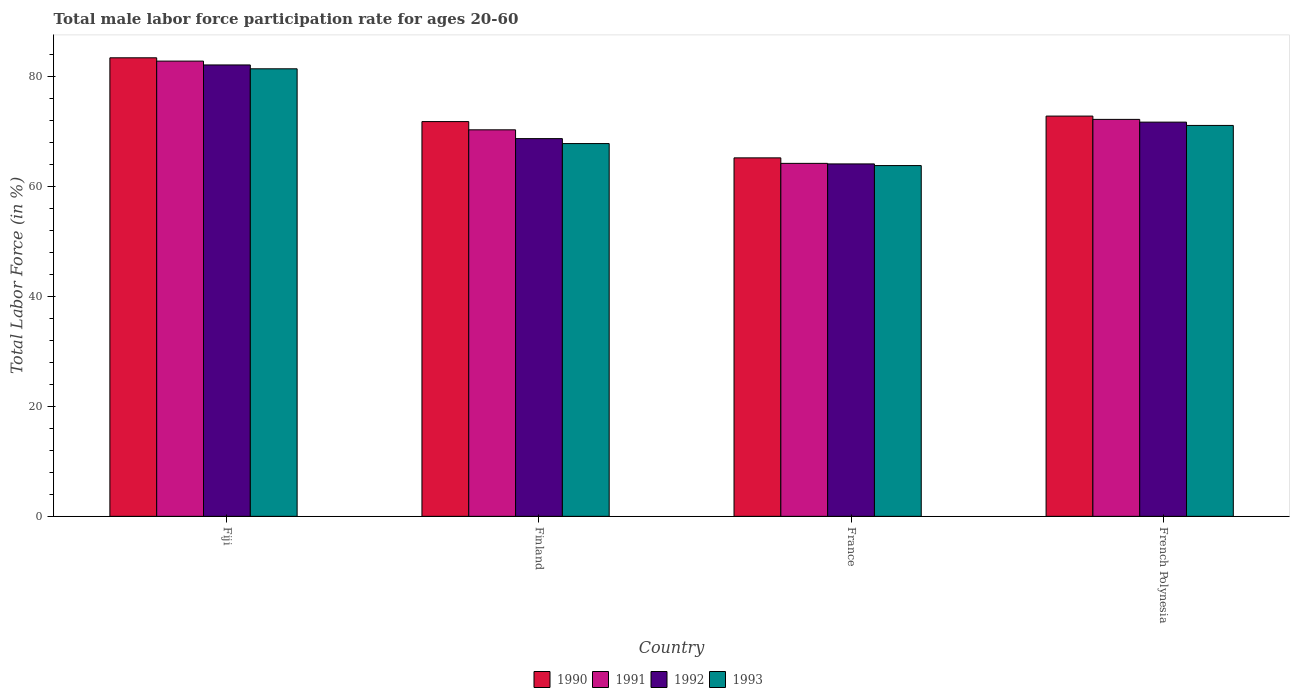How many bars are there on the 3rd tick from the right?
Keep it short and to the point. 4. What is the label of the 3rd group of bars from the left?
Keep it short and to the point. France. What is the male labor force participation rate in 1993 in Finland?
Provide a succinct answer. 67.8. Across all countries, what is the maximum male labor force participation rate in 1992?
Offer a terse response. 82.1. Across all countries, what is the minimum male labor force participation rate in 1990?
Give a very brief answer. 65.2. In which country was the male labor force participation rate in 1991 maximum?
Your answer should be compact. Fiji. What is the total male labor force participation rate in 1990 in the graph?
Your response must be concise. 293.2. What is the difference between the male labor force participation rate in 1992 in French Polynesia and the male labor force participation rate in 1990 in Fiji?
Offer a very short reply. -11.7. What is the average male labor force participation rate in 1990 per country?
Give a very brief answer. 73.3. What is the difference between the male labor force participation rate of/in 1993 and male labor force participation rate of/in 1992 in France?
Ensure brevity in your answer.  -0.3. What is the ratio of the male labor force participation rate in 1992 in Finland to that in French Polynesia?
Ensure brevity in your answer.  0.96. Is the male labor force participation rate in 1990 in Fiji less than that in French Polynesia?
Your answer should be very brief. No. What is the difference between the highest and the second highest male labor force participation rate in 1993?
Your response must be concise. 13.6. What is the difference between the highest and the lowest male labor force participation rate in 1993?
Your answer should be compact. 17.6. How many bars are there?
Your answer should be compact. 16. Are all the bars in the graph horizontal?
Your response must be concise. No. Are the values on the major ticks of Y-axis written in scientific E-notation?
Ensure brevity in your answer.  No. Does the graph contain any zero values?
Your answer should be compact. No. Does the graph contain grids?
Ensure brevity in your answer.  No. Where does the legend appear in the graph?
Your response must be concise. Bottom center. How many legend labels are there?
Give a very brief answer. 4. How are the legend labels stacked?
Your answer should be very brief. Horizontal. What is the title of the graph?
Give a very brief answer. Total male labor force participation rate for ages 20-60. Does "1982" appear as one of the legend labels in the graph?
Keep it short and to the point. No. What is the label or title of the Y-axis?
Ensure brevity in your answer.  Total Labor Force (in %). What is the Total Labor Force (in %) in 1990 in Fiji?
Provide a short and direct response. 83.4. What is the Total Labor Force (in %) in 1991 in Fiji?
Keep it short and to the point. 82.8. What is the Total Labor Force (in %) of 1992 in Fiji?
Offer a very short reply. 82.1. What is the Total Labor Force (in %) of 1993 in Fiji?
Your answer should be very brief. 81.4. What is the Total Labor Force (in %) of 1990 in Finland?
Give a very brief answer. 71.8. What is the Total Labor Force (in %) of 1991 in Finland?
Your response must be concise. 70.3. What is the Total Labor Force (in %) in 1992 in Finland?
Give a very brief answer. 68.7. What is the Total Labor Force (in %) in 1993 in Finland?
Make the answer very short. 67.8. What is the Total Labor Force (in %) of 1990 in France?
Offer a very short reply. 65.2. What is the Total Labor Force (in %) of 1991 in France?
Offer a very short reply. 64.2. What is the Total Labor Force (in %) of 1992 in France?
Make the answer very short. 64.1. What is the Total Labor Force (in %) of 1993 in France?
Provide a short and direct response. 63.8. What is the Total Labor Force (in %) in 1990 in French Polynesia?
Provide a short and direct response. 72.8. What is the Total Labor Force (in %) of 1991 in French Polynesia?
Your answer should be very brief. 72.2. What is the Total Labor Force (in %) of 1992 in French Polynesia?
Ensure brevity in your answer.  71.7. What is the Total Labor Force (in %) in 1993 in French Polynesia?
Your answer should be very brief. 71.1. Across all countries, what is the maximum Total Labor Force (in %) of 1990?
Your response must be concise. 83.4. Across all countries, what is the maximum Total Labor Force (in %) in 1991?
Offer a terse response. 82.8. Across all countries, what is the maximum Total Labor Force (in %) of 1992?
Your answer should be very brief. 82.1. Across all countries, what is the maximum Total Labor Force (in %) of 1993?
Offer a very short reply. 81.4. Across all countries, what is the minimum Total Labor Force (in %) of 1990?
Make the answer very short. 65.2. Across all countries, what is the minimum Total Labor Force (in %) of 1991?
Keep it short and to the point. 64.2. Across all countries, what is the minimum Total Labor Force (in %) of 1992?
Your answer should be very brief. 64.1. Across all countries, what is the minimum Total Labor Force (in %) of 1993?
Provide a short and direct response. 63.8. What is the total Total Labor Force (in %) in 1990 in the graph?
Offer a terse response. 293.2. What is the total Total Labor Force (in %) of 1991 in the graph?
Give a very brief answer. 289.5. What is the total Total Labor Force (in %) in 1992 in the graph?
Give a very brief answer. 286.6. What is the total Total Labor Force (in %) in 1993 in the graph?
Make the answer very short. 284.1. What is the difference between the Total Labor Force (in %) in 1990 in Fiji and that in Finland?
Give a very brief answer. 11.6. What is the difference between the Total Labor Force (in %) of 1991 in Fiji and that in Finland?
Ensure brevity in your answer.  12.5. What is the difference between the Total Labor Force (in %) in 1990 in Fiji and that in France?
Provide a short and direct response. 18.2. What is the difference between the Total Labor Force (in %) of 1992 in Fiji and that in France?
Offer a very short reply. 18. What is the difference between the Total Labor Force (in %) of 1990 in Fiji and that in French Polynesia?
Keep it short and to the point. 10.6. What is the difference between the Total Labor Force (in %) of 1991 in Fiji and that in French Polynesia?
Make the answer very short. 10.6. What is the difference between the Total Labor Force (in %) in 1993 in Fiji and that in French Polynesia?
Ensure brevity in your answer.  10.3. What is the difference between the Total Labor Force (in %) in 1990 in Finland and that in France?
Keep it short and to the point. 6.6. What is the difference between the Total Labor Force (in %) in 1992 in Finland and that in France?
Ensure brevity in your answer.  4.6. What is the difference between the Total Labor Force (in %) of 1990 in Finland and that in French Polynesia?
Your answer should be very brief. -1. What is the difference between the Total Labor Force (in %) in 1991 in Finland and that in French Polynesia?
Your answer should be compact. -1.9. What is the difference between the Total Labor Force (in %) in 1992 in Finland and that in French Polynesia?
Offer a very short reply. -3. What is the difference between the Total Labor Force (in %) of 1993 in Finland and that in French Polynesia?
Provide a short and direct response. -3.3. What is the difference between the Total Labor Force (in %) in 1991 in France and that in French Polynesia?
Ensure brevity in your answer.  -8. What is the difference between the Total Labor Force (in %) in 1990 in Fiji and the Total Labor Force (in %) in 1991 in Finland?
Give a very brief answer. 13.1. What is the difference between the Total Labor Force (in %) in 1990 in Fiji and the Total Labor Force (in %) in 1993 in Finland?
Ensure brevity in your answer.  15.6. What is the difference between the Total Labor Force (in %) of 1991 in Fiji and the Total Labor Force (in %) of 1992 in Finland?
Provide a short and direct response. 14.1. What is the difference between the Total Labor Force (in %) of 1991 in Fiji and the Total Labor Force (in %) of 1993 in Finland?
Ensure brevity in your answer.  15. What is the difference between the Total Labor Force (in %) in 1990 in Fiji and the Total Labor Force (in %) in 1991 in France?
Your answer should be very brief. 19.2. What is the difference between the Total Labor Force (in %) in 1990 in Fiji and the Total Labor Force (in %) in 1992 in France?
Your answer should be very brief. 19.3. What is the difference between the Total Labor Force (in %) of 1990 in Fiji and the Total Labor Force (in %) of 1993 in France?
Your answer should be compact. 19.6. What is the difference between the Total Labor Force (in %) in 1991 in Fiji and the Total Labor Force (in %) in 1992 in France?
Ensure brevity in your answer.  18.7. What is the difference between the Total Labor Force (in %) of 1990 in Fiji and the Total Labor Force (in %) of 1991 in French Polynesia?
Offer a very short reply. 11.2. What is the difference between the Total Labor Force (in %) of 1990 in Fiji and the Total Labor Force (in %) of 1992 in French Polynesia?
Your answer should be very brief. 11.7. What is the difference between the Total Labor Force (in %) in 1991 in Fiji and the Total Labor Force (in %) in 1992 in French Polynesia?
Provide a succinct answer. 11.1. What is the difference between the Total Labor Force (in %) in 1990 in Finland and the Total Labor Force (in %) in 1993 in France?
Keep it short and to the point. 8. What is the difference between the Total Labor Force (in %) of 1991 in Finland and the Total Labor Force (in %) of 1992 in France?
Your answer should be compact. 6.2. What is the difference between the Total Labor Force (in %) of 1992 in Finland and the Total Labor Force (in %) of 1993 in France?
Offer a terse response. 4.9. What is the difference between the Total Labor Force (in %) of 1990 in Finland and the Total Labor Force (in %) of 1993 in French Polynesia?
Your answer should be very brief. 0.7. What is the difference between the Total Labor Force (in %) of 1991 in Finland and the Total Labor Force (in %) of 1992 in French Polynesia?
Offer a terse response. -1.4. What is the difference between the Total Labor Force (in %) of 1990 in France and the Total Labor Force (in %) of 1991 in French Polynesia?
Offer a terse response. -7. What is the difference between the Total Labor Force (in %) in 1990 in France and the Total Labor Force (in %) in 1992 in French Polynesia?
Your response must be concise. -6.5. What is the difference between the Total Labor Force (in %) in 1990 in France and the Total Labor Force (in %) in 1993 in French Polynesia?
Provide a short and direct response. -5.9. What is the average Total Labor Force (in %) of 1990 per country?
Give a very brief answer. 73.3. What is the average Total Labor Force (in %) of 1991 per country?
Your response must be concise. 72.38. What is the average Total Labor Force (in %) in 1992 per country?
Offer a terse response. 71.65. What is the average Total Labor Force (in %) in 1993 per country?
Keep it short and to the point. 71.03. What is the difference between the Total Labor Force (in %) in 1991 and Total Labor Force (in %) in 1993 in Fiji?
Keep it short and to the point. 1.4. What is the difference between the Total Labor Force (in %) of 1992 and Total Labor Force (in %) of 1993 in Fiji?
Make the answer very short. 0.7. What is the difference between the Total Labor Force (in %) in 1990 and Total Labor Force (in %) in 1992 in Finland?
Ensure brevity in your answer.  3.1. What is the difference between the Total Labor Force (in %) in 1990 and Total Labor Force (in %) in 1991 in France?
Provide a short and direct response. 1. What is the difference between the Total Labor Force (in %) of 1990 and Total Labor Force (in %) of 1992 in France?
Make the answer very short. 1.1. What is the difference between the Total Labor Force (in %) of 1991 and Total Labor Force (in %) of 1992 in France?
Provide a short and direct response. 0.1. What is the difference between the Total Labor Force (in %) in 1991 and Total Labor Force (in %) in 1993 in France?
Offer a very short reply. 0.4. What is the difference between the Total Labor Force (in %) of 1990 and Total Labor Force (in %) of 1992 in French Polynesia?
Provide a short and direct response. 1.1. What is the difference between the Total Labor Force (in %) in 1990 and Total Labor Force (in %) in 1993 in French Polynesia?
Ensure brevity in your answer.  1.7. What is the difference between the Total Labor Force (in %) of 1991 and Total Labor Force (in %) of 1993 in French Polynesia?
Provide a short and direct response. 1.1. What is the ratio of the Total Labor Force (in %) of 1990 in Fiji to that in Finland?
Make the answer very short. 1.16. What is the ratio of the Total Labor Force (in %) in 1991 in Fiji to that in Finland?
Make the answer very short. 1.18. What is the ratio of the Total Labor Force (in %) of 1992 in Fiji to that in Finland?
Your response must be concise. 1.2. What is the ratio of the Total Labor Force (in %) in 1993 in Fiji to that in Finland?
Provide a short and direct response. 1.2. What is the ratio of the Total Labor Force (in %) of 1990 in Fiji to that in France?
Your answer should be very brief. 1.28. What is the ratio of the Total Labor Force (in %) in 1991 in Fiji to that in France?
Provide a short and direct response. 1.29. What is the ratio of the Total Labor Force (in %) in 1992 in Fiji to that in France?
Offer a terse response. 1.28. What is the ratio of the Total Labor Force (in %) in 1993 in Fiji to that in France?
Provide a short and direct response. 1.28. What is the ratio of the Total Labor Force (in %) in 1990 in Fiji to that in French Polynesia?
Make the answer very short. 1.15. What is the ratio of the Total Labor Force (in %) of 1991 in Fiji to that in French Polynesia?
Offer a very short reply. 1.15. What is the ratio of the Total Labor Force (in %) in 1992 in Fiji to that in French Polynesia?
Your response must be concise. 1.15. What is the ratio of the Total Labor Force (in %) in 1993 in Fiji to that in French Polynesia?
Provide a short and direct response. 1.14. What is the ratio of the Total Labor Force (in %) in 1990 in Finland to that in France?
Ensure brevity in your answer.  1.1. What is the ratio of the Total Labor Force (in %) of 1991 in Finland to that in France?
Ensure brevity in your answer.  1.09. What is the ratio of the Total Labor Force (in %) of 1992 in Finland to that in France?
Ensure brevity in your answer.  1.07. What is the ratio of the Total Labor Force (in %) in 1993 in Finland to that in France?
Give a very brief answer. 1.06. What is the ratio of the Total Labor Force (in %) in 1990 in Finland to that in French Polynesia?
Give a very brief answer. 0.99. What is the ratio of the Total Labor Force (in %) of 1991 in Finland to that in French Polynesia?
Ensure brevity in your answer.  0.97. What is the ratio of the Total Labor Force (in %) in 1992 in Finland to that in French Polynesia?
Provide a succinct answer. 0.96. What is the ratio of the Total Labor Force (in %) of 1993 in Finland to that in French Polynesia?
Provide a succinct answer. 0.95. What is the ratio of the Total Labor Force (in %) in 1990 in France to that in French Polynesia?
Provide a succinct answer. 0.9. What is the ratio of the Total Labor Force (in %) in 1991 in France to that in French Polynesia?
Keep it short and to the point. 0.89. What is the ratio of the Total Labor Force (in %) of 1992 in France to that in French Polynesia?
Provide a succinct answer. 0.89. What is the ratio of the Total Labor Force (in %) in 1993 in France to that in French Polynesia?
Give a very brief answer. 0.9. What is the difference between the highest and the second highest Total Labor Force (in %) of 1990?
Your answer should be very brief. 10.6. What is the difference between the highest and the lowest Total Labor Force (in %) of 1992?
Offer a very short reply. 18. 